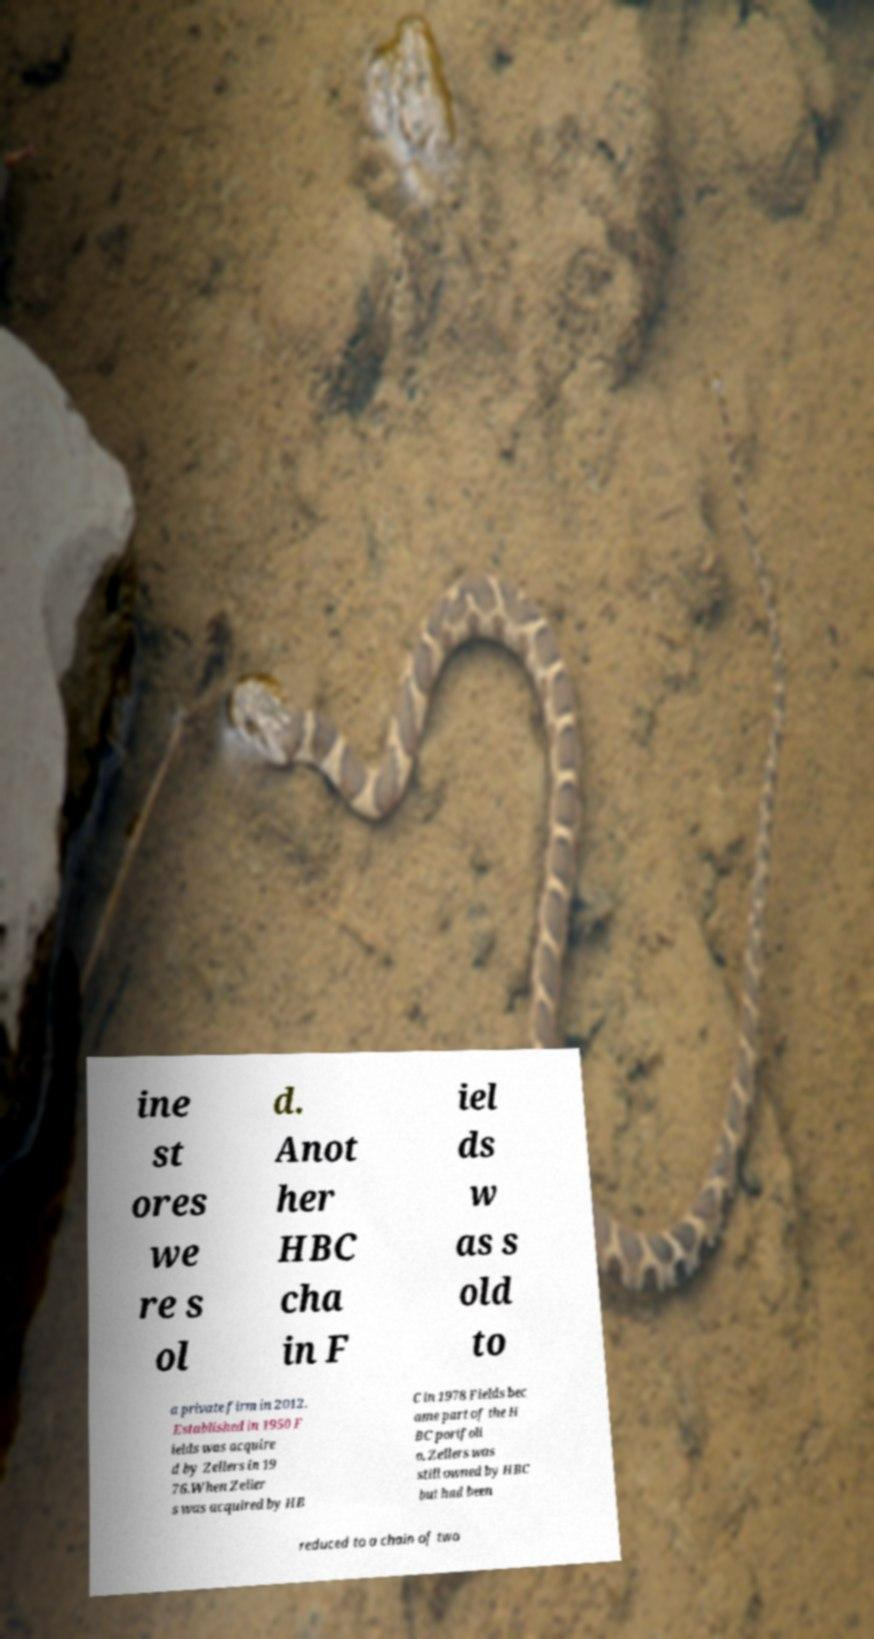Please read and relay the text visible in this image. What does it say? ine st ores we re s ol d. Anot her HBC cha in F iel ds w as s old to a private firm in 2012. Established in 1950 F ields was acquire d by Zellers in 19 76.When Zeller s was acquired by HB C in 1978 Fields bec ame part of the H BC portfoli o. Zellers was still owned by HBC but had been reduced to a chain of two 